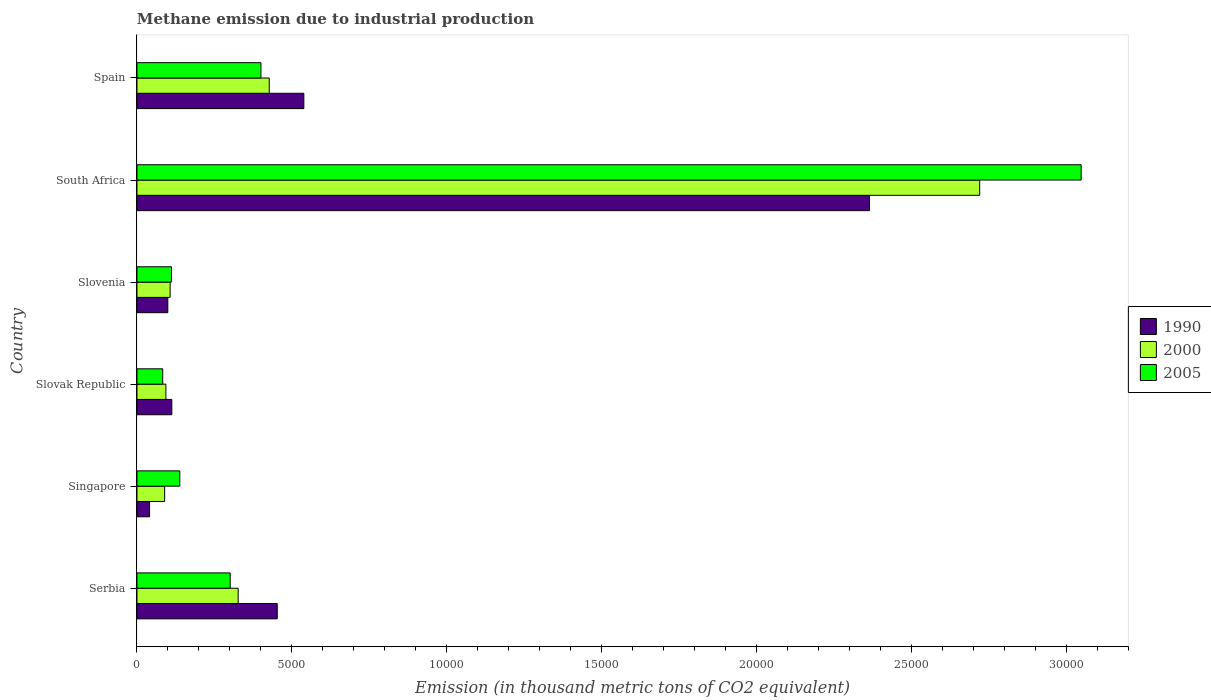Are the number of bars per tick equal to the number of legend labels?
Ensure brevity in your answer.  Yes. Are the number of bars on each tick of the Y-axis equal?
Give a very brief answer. Yes. What is the label of the 3rd group of bars from the top?
Offer a very short reply. Slovenia. In how many cases, is the number of bars for a given country not equal to the number of legend labels?
Give a very brief answer. 0. What is the amount of methane emitted in 2005 in Singapore?
Offer a terse response. 1383. Across all countries, what is the maximum amount of methane emitted in 2005?
Your answer should be compact. 3.05e+04. Across all countries, what is the minimum amount of methane emitted in 2005?
Keep it short and to the point. 830.9. In which country was the amount of methane emitted in 2005 maximum?
Give a very brief answer. South Africa. In which country was the amount of methane emitted in 2005 minimum?
Ensure brevity in your answer.  Slovak Republic. What is the total amount of methane emitted in 2005 in the graph?
Your response must be concise. 4.08e+04. What is the difference between the amount of methane emitted in 2005 in Serbia and that in Slovenia?
Provide a succinct answer. 1896. What is the difference between the amount of methane emitted in 1990 in Serbia and the amount of methane emitted in 2000 in Singapore?
Offer a very short reply. 3635.6. What is the average amount of methane emitted in 1990 per country?
Your answer should be compact. 6015.77. What is the difference between the amount of methane emitted in 2005 and amount of methane emitted in 1990 in Singapore?
Offer a very short reply. 976.2. What is the ratio of the amount of methane emitted in 2000 in Slovenia to that in South Africa?
Your response must be concise. 0.04. Is the difference between the amount of methane emitted in 2005 in Serbia and South Africa greater than the difference between the amount of methane emitted in 1990 in Serbia and South Africa?
Your answer should be very brief. No. What is the difference between the highest and the second highest amount of methane emitted in 2005?
Offer a very short reply. 2.65e+04. What is the difference between the highest and the lowest amount of methane emitted in 2005?
Provide a short and direct response. 2.97e+04. In how many countries, is the amount of methane emitted in 2005 greater than the average amount of methane emitted in 2005 taken over all countries?
Your answer should be compact. 1. What does the 1st bar from the bottom in Serbia represents?
Make the answer very short. 1990. Are all the bars in the graph horizontal?
Your response must be concise. Yes. What is the difference between two consecutive major ticks on the X-axis?
Your response must be concise. 5000. Does the graph contain any zero values?
Give a very brief answer. No. Where does the legend appear in the graph?
Offer a terse response. Center right. How many legend labels are there?
Your answer should be very brief. 3. What is the title of the graph?
Provide a short and direct response. Methane emission due to industrial production. Does "2007" appear as one of the legend labels in the graph?
Make the answer very short. No. What is the label or title of the X-axis?
Offer a very short reply. Emission (in thousand metric tons of CO2 equivalent). What is the Emission (in thousand metric tons of CO2 equivalent) of 1990 in Serbia?
Provide a succinct answer. 4529.1. What is the Emission (in thousand metric tons of CO2 equivalent) in 2000 in Serbia?
Your answer should be compact. 3267.7. What is the Emission (in thousand metric tons of CO2 equivalent) of 2005 in Serbia?
Offer a terse response. 3010.4. What is the Emission (in thousand metric tons of CO2 equivalent) of 1990 in Singapore?
Provide a succinct answer. 406.8. What is the Emission (in thousand metric tons of CO2 equivalent) of 2000 in Singapore?
Keep it short and to the point. 893.5. What is the Emission (in thousand metric tons of CO2 equivalent) in 2005 in Singapore?
Your answer should be very brief. 1383. What is the Emission (in thousand metric tons of CO2 equivalent) of 1990 in Slovak Republic?
Your answer should be compact. 1125.1. What is the Emission (in thousand metric tons of CO2 equivalent) of 2000 in Slovak Republic?
Keep it short and to the point. 934.1. What is the Emission (in thousand metric tons of CO2 equivalent) in 2005 in Slovak Republic?
Your response must be concise. 830.9. What is the Emission (in thousand metric tons of CO2 equivalent) of 1990 in Slovenia?
Your response must be concise. 996.3. What is the Emission (in thousand metric tons of CO2 equivalent) of 2000 in Slovenia?
Your response must be concise. 1071.1. What is the Emission (in thousand metric tons of CO2 equivalent) of 2005 in Slovenia?
Offer a very short reply. 1114.4. What is the Emission (in thousand metric tons of CO2 equivalent) of 1990 in South Africa?
Your answer should be very brief. 2.36e+04. What is the Emission (in thousand metric tons of CO2 equivalent) of 2000 in South Africa?
Provide a succinct answer. 2.72e+04. What is the Emission (in thousand metric tons of CO2 equivalent) of 2005 in South Africa?
Offer a very short reply. 3.05e+04. What is the Emission (in thousand metric tons of CO2 equivalent) in 1990 in Spain?
Give a very brief answer. 5387.8. What is the Emission (in thousand metric tons of CO2 equivalent) in 2000 in Spain?
Ensure brevity in your answer.  4271. What is the Emission (in thousand metric tons of CO2 equivalent) in 2005 in Spain?
Provide a succinct answer. 4002.6. Across all countries, what is the maximum Emission (in thousand metric tons of CO2 equivalent) in 1990?
Provide a succinct answer. 2.36e+04. Across all countries, what is the maximum Emission (in thousand metric tons of CO2 equivalent) in 2000?
Your answer should be compact. 2.72e+04. Across all countries, what is the maximum Emission (in thousand metric tons of CO2 equivalent) in 2005?
Your answer should be compact. 3.05e+04. Across all countries, what is the minimum Emission (in thousand metric tons of CO2 equivalent) in 1990?
Keep it short and to the point. 406.8. Across all countries, what is the minimum Emission (in thousand metric tons of CO2 equivalent) of 2000?
Provide a short and direct response. 893.5. Across all countries, what is the minimum Emission (in thousand metric tons of CO2 equivalent) in 2005?
Make the answer very short. 830.9. What is the total Emission (in thousand metric tons of CO2 equivalent) of 1990 in the graph?
Your answer should be compact. 3.61e+04. What is the total Emission (in thousand metric tons of CO2 equivalent) of 2000 in the graph?
Your answer should be very brief. 3.76e+04. What is the total Emission (in thousand metric tons of CO2 equivalent) in 2005 in the graph?
Keep it short and to the point. 4.08e+04. What is the difference between the Emission (in thousand metric tons of CO2 equivalent) of 1990 in Serbia and that in Singapore?
Offer a very short reply. 4122.3. What is the difference between the Emission (in thousand metric tons of CO2 equivalent) of 2000 in Serbia and that in Singapore?
Provide a succinct answer. 2374.2. What is the difference between the Emission (in thousand metric tons of CO2 equivalent) of 2005 in Serbia and that in Singapore?
Your response must be concise. 1627.4. What is the difference between the Emission (in thousand metric tons of CO2 equivalent) of 1990 in Serbia and that in Slovak Republic?
Offer a terse response. 3404. What is the difference between the Emission (in thousand metric tons of CO2 equivalent) in 2000 in Serbia and that in Slovak Republic?
Your answer should be very brief. 2333.6. What is the difference between the Emission (in thousand metric tons of CO2 equivalent) of 2005 in Serbia and that in Slovak Republic?
Your response must be concise. 2179.5. What is the difference between the Emission (in thousand metric tons of CO2 equivalent) of 1990 in Serbia and that in Slovenia?
Ensure brevity in your answer.  3532.8. What is the difference between the Emission (in thousand metric tons of CO2 equivalent) of 2000 in Serbia and that in Slovenia?
Offer a very short reply. 2196.6. What is the difference between the Emission (in thousand metric tons of CO2 equivalent) in 2005 in Serbia and that in Slovenia?
Offer a very short reply. 1896. What is the difference between the Emission (in thousand metric tons of CO2 equivalent) of 1990 in Serbia and that in South Africa?
Provide a short and direct response. -1.91e+04. What is the difference between the Emission (in thousand metric tons of CO2 equivalent) in 2000 in Serbia and that in South Africa?
Provide a succinct answer. -2.39e+04. What is the difference between the Emission (in thousand metric tons of CO2 equivalent) in 2005 in Serbia and that in South Africa?
Offer a very short reply. -2.75e+04. What is the difference between the Emission (in thousand metric tons of CO2 equivalent) in 1990 in Serbia and that in Spain?
Keep it short and to the point. -858.7. What is the difference between the Emission (in thousand metric tons of CO2 equivalent) of 2000 in Serbia and that in Spain?
Ensure brevity in your answer.  -1003.3. What is the difference between the Emission (in thousand metric tons of CO2 equivalent) of 2005 in Serbia and that in Spain?
Provide a short and direct response. -992.2. What is the difference between the Emission (in thousand metric tons of CO2 equivalent) in 1990 in Singapore and that in Slovak Republic?
Your answer should be compact. -718.3. What is the difference between the Emission (in thousand metric tons of CO2 equivalent) of 2000 in Singapore and that in Slovak Republic?
Provide a short and direct response. -40.6. What is the difference between the Emission (in thousand metric tons of CO2 equivalent) in 2005 in Singapore and that in Slovak Republic?
Your answer should be compact. 552.1. What is the difference between the Emission (in thousand metric tons of CO2 equivalent) in 1990 in Singapore and that in Slovenia?
Offer a very short reply. -589.5. What is the difference between the Emission (in thousand metric tons of CO2 equivalent) of 2000 in Singapore and that in Slovenia?
Make the answer very short. -177.6. What is the difference between the Emission (in thousand metric tons of CO2 equivalent) of 2005 in Singapore and that in Slovenia?
Provide a short and direct response. 268.6. What is the difference between the Emission (in thousand metric tons of CO2 equivalent) of 1990 in Singapore and that in South Africa?
Your answer should be compact. -2.32e+04. What is the difference between the Emission (in thousand metric tons of CO2 equivalent) of 2000 in Singapore and that in South Africa?
Your response must be concise. -2.63e+04. What is the difference between the Emission (in thousand metric tons of CO2 equivalent) of 2005 in Singapore and that in South Africa?
Offer a very short reply. -2.91e+04. What is the difference between the Emission (in thousand metric tons of CO2 equivalent) of 1990 in Singapore and that in Spain?
Offer a terse response. -4981. What is the difference between the Emission (in thousand metric tons of CO2 equivalent) in 2000 in Singapore and that in Spain?
Offer a terse response. -3377.5. What is the difference between the Emission (in thousand metric tons of CO2 equivalent) of 2005 in Singapore and that in Spain?
Ensure brevity in your answer.  -2619.6. What is the difference between the Emission (in thousand metric tons of CO2 equivalent) in 1990 in Slovak Republic and that in Slovenia?
Provide a short and direct response. 128.8. What is the difference between the Emission (in thousand metric tons of CO2 equivalent) of 2000 in Slovak Republic and that in Slovenia?
Offer a very short reply. -137. What is the difference between the Emission (in thousand metric tons of CO2 equivalent) of 2005 in Slovak Republic and that in Slovenia?
Ensure brevity in your answer.  -283.5. What is the difference between the Emission (in thousand metric tons of CO2 equivalent) in 1990 in Slovak Republic and that in South Africa?
Make the answer very short. -2.25e+04. What is the difference between the Emission (in thousand metric tons of CO2 equivalent) in 2000 in Slovak Republic and that in South Africa?
Your answer should be compact. -2.63e+04. What is the difference between the Emission (in thousand metric tons of CO2 equivalent) of 2005 in Slovak Republic and that in South Africa?
Ensure brevity in your answer.  -2.97e+04. What is the difference between the Emission (in thousand metric tons of CO2 equivalent) of 1990 in Slovak Republic and that in Spain?
Your response must be concise. -4262.7. What is the difference between the Emission (in thousand metric tons of CO2 equivalent) in 2000 in Slovak Republic and that in Spain?
Your response must be concise. -3336.9. What is the difference between the Emission (in thousand metric tons of CO2 equivalent) of 2005 in Slovak Republic and that in Spain?
Ensure brevity in your answer.  -3171.7. What is the difference between the Emission (in thousand metric tons of CO2 equivalent) of 1990 in Slovenia and that in South Africa?
Your answer should be compact. -2.27e+04. What is the difference between the Emission (in thousand metric tons of CO2 equivalent) in 2000 in Slovenia and that in South Africa?
Your answer should be very brief. -2.61e+04. What is the difference between the Emission (in thousand metric tons of CO2 equivalent) of 2005 in Slovenia and that in South Africa?
Offer a terse response. -2.94e+04. What is the difference between the Emission (in thousand metric tons of CO2 equivalent) in 1990 in Slovenia and that in Spain?
Give a very brief answer. -4391.5. What is the difference between the Emission (in thousand metric tons of CO2 equivalent) of 2000 in Slovenia and that in Spain?
Keep it short and to the point. -3199.9. What is the difference between the Emission (in thousand metric tons of CO2 equivalent) in 2005 in Slovenia and that in Spain?
Provide a short and direct response. -2888.2. What is the difference between the Emission (in thousand metric tons of CO2 equivalent) in 1990 in South Africa and that in Spain?
Offer a very short reply. 1.83e+04. What is the difference between the Emission (in thousand metric tons of CO2 equivalent) in 2000 in South Africa and that in Spain?
Provide a succinct answer. 2.29e+04. What is the difference between the Emission (in thousand metric tons of CO2 equivalent) in 2005 in South Africa and that in Spain?
Offer a very short reply. 2.65e+04. What is the difference between the Emission (in thousand metric tons of CO2 equivalent) in 1990 in Serbia and the Emission (in thousand metric tons of CO2 equivalent) in 2000 in Singapore?
Make the answer very short. 3635.6. What is the difference between the Emission (in thousand metric tons of CO2 equivalent) of 1990 in Serbia and the Emission (in thousand metric tons of CO2 equivalent) of 2005 in Singapore?
Your response must be concise. 3146.1. What is the difference between the Emission (in thousand metric tons of CO2 equivalent) of 2000 in Serbia and the Emission (in thousand metric tons of CO2 equivalent) of 2005 in Singapore?
Ensure brevity in your answer.  1884.7. What is the difference between the Emission (in thousand metric tons of CO2 equivalent) of 1990 in Serbia and the Emission (in thousand metric tons of CO2 equivalent) of 2000 in Slovak Republic?
Offer a terse response. 3595. What is the difference between the Emission (in thousand metric tons of CO2 equivalent) in 1990 in Serbia and the Emission (in thousand metric tons of CO2 equivalent) in 2005 in Slovak Republic?
Offer a very short reply. 3698.2. What is the difference between the Emission (in thousand metric tons of CO2 equivalent) of 2000 in Serbia and the Emission (in thousand metric tons of CO2 equivalent) of 2005 in Slovak Republic?
Make the answer very short. 2436.8. What is the difference between the Emission (in thousand metric tons of CO2 equivalent) in 1990 in Serbia and the Emission (in thousand metric tons of CO2 equivalent) in 2000 in Slovenia?
Give a very brief answer. 3458. What is the difference between the Emission (in thousand metric tons of CO2 equivalent) of 1990 in Serbia and the Emission (in thousand metric tons of CO2 equivalent) of 2005 in Slovenia?
Your response must be concise. 3414.7. What is the difference between the Emission (in thousand metric tons of CO2 equivalent) in 2000 in Serbia and the Emission (in thousand metric tons of CO2 equivalent) in 2005 in Slovenia?
Offer a terse response. 2153.3. What is the difference between the Emission (in thousand metric tons of CO2 equivalent) in 1990 in Serbia and the Emission (in thousand metric tons of CO2 equivalent) in 2000 in South Africa?
Make the answer very short. -2.27e+04. What is the difference between the Emission (in thousand metric tons of CO2 equivalent) in 1990 in Serbia and the Emission (in thousand metric tons of CO2 equivalent) in 2005 in South Africa?
Your answer should be very brief. -2.60e+04. What is the difference between the Emission (in thousand metric tons of CO2 equivalent) in 2000 in Serbia and the Emission (in thousand metric tons of CO2 equivalent) in 2005 in South Africa?
Offer a very short reply. -2.72e+04. What is the difference between the Emission (in thousand metric tons of CO2 equivalent) in 1990 in Serbia and the Emission (in thousand metric tons of CO2 equivalent) in 2000 in Spain?
Offer a very short reply. 258.1. What is the difference between the Emission (in thousand metric tons of CO2 equivalent) in 1990 in Serbia and the Emission (in thousand metric tons of CO2 equivalent) in 2005 in Spain?
Make the answer very short. 526.5. What is the difference between the Emission (in thousand metric tons of CO2 equivalent) in 2000 in Serbia and the Emission (in thousand metric tons of CO2 equivalent) in 2005 in Spain?
Give a very brief answer. -734.9. What is the difference between the Emission (in thousand metric tons of CO2 equivalent) in 1990 in Singapore and the Emission (in thousand metric tons of CO2 equivalent) in 2000 in Slovak Republic?
Provide a short and direct response. -527.3. What is the difference between the Emission (in thousand metric tons of CO2 equivalent) in 1990 in Singapore and the Emission (in thousand metric tons of CO2 equivalent) in 2005 in Slovak Republic?
Offer a terse response. -424.1. What is the difference between the Emission (in thousand metric tons of CO2 equivalent) of 2000 in Singapore and the Emission (in thousand metric tons of CO2 equivalent) of 2005 in Slovak Republic?
Your answer should be very brief. 62.6. What is the difference between the Emission (in thousand metric tons of CO2 equivalent) in 1990 in Singapore and the Emission (in thousand metric tons of CO2 equivalent) in 2000 in Slovenia?
Offer a terse response. -664.3. What is the difference between the Emission (in thousand metric tons of CO2 equivalent) of 1990 in Singapore and the Emission (in thousand metric tons of CO2 equivalent) of 2005 in Slovenia?
Make the answer very short. -707.6. What is the difference between the Emission (in thousand metric tons of CO2 equivalent) in 2000 in Singapore and the Emission (in thousand metric tons of CO2 equivalent) in 2005 in Slovenia?
Keep it short and to the point. -220.9. What is the difference between the Emission (in thousand metric tons of CO2 equivalent) of 1990 in Singapore and the Emission (in thousand metric tons of CO2 equivalent) of 2000 in South Africa?
Offer a very short reply. -2.68e+04. What is the difference between the Emission (in thousand metric tons of CO2 equivalent) in 1990 in Singapore and the Emission (in thousand metric tons of CO2 equivalent) in 2005 in South Africa?
Ensure brevity in your answer.  -3.01e+04. What is the difference between the Emission (in thousand metric tons of CO2 equivalent) in 2000 in Singapore and the Emission (in thousand metric tons of CO2 equivalent) in 2005 in South Africa?
Give a very brief answer. -2.96e+04. What is the difference between the Emission (in thousand metric tons of CO2 equivalent) in 1990 in Singapore and the Emission (in thousand metric tons of CO2 equivalent) in 2000 in Spain?
Provide a succinct answer. -3864.2. What is the difference between the Emission (in thousand metric tons of CO2 equivalent) in 1990 in Singapore and the Emission (in thousand metric tons of CO2 equivalent) in 2005 in Spain?
Your response must be concise. -3595.8. What is the difference between the Emission (in thousand metric tons of CO2 equivalent) of 2000 in Singapore and the Emission (in thousand metric tons of CO2 equivalent) of 2005 in Spain?
Give a very brief answer. -3109.1. What is the difference between the Emission (in thousand metric tons of CO2 equivalent) of 2000 in Slovak Republic and the Emission (in thousand metric tons of CO2 equivalent) of 2005 in Slovenia?
Give a very brief answer. -180.3. What is the difference between the Emission (in thousand metric tons of CO2 equivalent) of 1990 in Slovak Republic and the Emission (in thousand metric tons of CO2 equivalent) of 2000 in South Africa?
Offer a terse response. -2.61e+04. What is the difference between the Emission (in thousand metric tons of CO2 equivalent) of 1990 in Slovak Republic and the Emission (in thousand metric tons of CO2 equivalent) of 2005 in South Africa?
Offer a terse response. -2.94e+04. What is the difference between the Emission (in thousand metric tons of CO2 equivalent) of 2000 in Slovak Republic and the Emission (in thousand metric tons of CO2 equivalent) of 2005 in South Africa?
Your answer should be compact. -2.96e+04. What is the difference between the Emission (in thousand metric tons of CO2 equivalent) of 1990 in Slovak Republic and the Emission (in thousand metric tons of CO2 equivalent) of 2000 in Spain?
Your answer should be compact. -3145.9. What is the difference between the Emission (in thousand metric tons of CO2 equivalent) in 1990 in Slovak Republic and the Emission (in thousand metric tons of CO2 equivalent) in 2005 in Spain?
Your answer should be very brief. -2877.5. What is the difference between the Emission (in thousand metric tons of CO2 equivalent) in 2000 in Slovak Republic and the Emission (in thousand metric tons of CO2 equivalent) in 2005 in Spain?
Your answer should be compact. -3068.5. What is the difference between the Emission (in thousand metric tons of CO2 equivalent) in 1990 in Slovenia and the Emission (in thousand metric tons of CO2 equivalent) in 2000 in South Africa?
Your answer should be compact. -2.62e+04. What is the difference between the Emission (in thousand metric tons of CO2 equivalent) in 1990 in Slovenia and the Emission (in thousand metric tons of CO2 equivalent) in 2005 in South Africa?
Keep it short and to the point. -2.95e+04. What is the difference between the Emission (in thousand metric tons of CO2 equivalent) in 2000 in Slovenia and the Emission (in thousand metric tons of CO2 equivalent) in 2005 in South Africa?
Your answer should be compact. -2.94e+04. What is the difference between the Emission (in thousand metric tons of CO2 equivalent) of 1990 in Slovenia and the Emission (in thousand metric tons of CO2 equivalent) of 2000 in Spain?
Offer a very short reply. -3274.7. What is the difference between the Emission (in thousand metric tons of CO2 equivalent) in 1990 in Slovenia and the Emission (in thousand metric tons of CO2 equivalent) in 2005 in Spain?
Keep it short and to the point. -3006.3. What is the difference between the Emission (in thousand metric tons of CO2 equivalent) in 2000 in Slovenia and the Emission (in thousand metric tons of CO2 equivalent) in 2005 in Spain?
Provide a short and direct response. -2931.5. What is the difference between the Emission (in thousand metric tons of CO2 equivalent) of 1990 in South Africa and the Emission (in thousand metric tons of CO2 equivalent) of 2000 in Spain?
Offer a terse response. 1.94e+04. What is the difference between the Emission (in thousand metric tons of CO2 equivalent) of 1990 in South Africa and the Emission (in thousand metric tons of CO2 equivalent) of 2005 in Spain?
Give a very brief answer. 1.96e+04. What is the difference between the Emission (in thousand metric tons of CO2 equivalent) of 2000 in South Africa and the Emission (in thousand metric tons of CO2 equivalent) of 2005 in Spain?
Make the answer very short. 2.32e+04. What is the average Emission (in thousand metric tons of CO2 equivalent) of 1990 per country?
Make the answer very short. 6015.77. What is the average Emission (in thousand metric tons of CO2 equivalent) of 2000 per country?
Your answer should be compact. 6274.2. What is the average Emission (in thousand metric tons of CO2 equivalent) in 2005 per country?
Make the answer very short. 6804.27. What is the difference between the Emission (in thousand metric tons of CO2 equivalent) in 1990 and Emission (in thousand metric tons of CO2 equivalent) in 2000 in Serbia?
Offer a very short reply. 1261.4. What is the difference between the Emission (in thousand metric tons of CO2 equivalent) of 1990 and Emission (in thousand metric tons of CO2 equivalent) of 2005 in Serbia?
Ensure brevity in your answer.  1518.7. What is the difference between the Emission (in thousand metric tons of CO2 equivalent) in 2000 and Emission (in thousand metric tons of CO2 equivalent) in 2005 in Serbia?
Give a very brief answer. 257.3. What is the difference between the Emission (in thousand metric tons of CO2 equivalent) of 1990 and Emission (in thousand metric tons of CO2 equivalent) of 2000 in Singapore?
Provide a succinct answer. -486.7. What is the difference between the Emission (in thousand metric tons of CO2 equivalent) in 1990 and Emission (in thousand metric tons of CO2 equivalent) in 2005 in Singapore?
Provide a short and direct response. -976.2. What is the difference between the Emission (in thousand metric tons of CO2 equivalent) in 2000 and Emission (in thousand metric tons of CO2 equivalent) in 2005 in Singapore?
Your answer should be very brief. -489.5. What is the difference between the Emission (in thousand metric tons of CO2 equivalent) of 1990 and Emission (in thousand metric tons of CO2 equivalent) of 2000 in Slovak Republic?
Ensure brevity in your answer.  191. What is the difference between the Emission (in thousand metric tons of CO2 equivalent) of 1990 and Emission (in thousand metric tons of CO2 equivalent) of 2005 in Slovak Republic?
Offer a very short reply. 294.2. What is the difference between the Emission (in thousand metric tons of CO2 equivalent) of 2000 and Emission (in thousand metric tons of CO2 equivalent) of 2005 in Slovak Republic?
Your answer should be compact. 103.2. What is the difference between the Emission (in thousand metric tons of CO2 equivalent) in 1990 and Emission (in thousand metric tons of CO2 equivalent) in 2000 in Slovenia?
Keep it short and to the point. -74.8. What is the difference between the Emission (in thousand metric tons of CO2 equivalent) in 1990 and Emission (in thousand metric tons of CO2 equivalent) in 2005 in Slovenia?
Your response must be concise. -118.1. What is the difference between the Emission (in thousand metric tons of CO2 equivalent) in 2000 and Emission (in thousand metric tons of CO2 equivalent) in 2005 in Slovenia?
Ensure brevity in your answer.  -43.3. What is the difference between the Emission (in thousand metric tons of CO2 equivalent) in 1990 and Emission (in thousand metric tons of CO2 equivalent) in 2000 in South Africa?
Your response must be concise. -3558.3. What is the difference between the Emission (in thousand metric tons of CO2 equivalent) in 1990 and Emission (in thousand metric tons of CO2 equivalent) in 2005 in South Africa?
Give a very brief answer. -6834.8. What is the difference between the Emission (in thousand metric tons of CO2 equivalent) in 2000 and Emission (in thousand metric tons of CO2 equivalent) in 2005 in South Africa?
Keep it short and to the point. -3276.5. What is the difference between the Emission (in thousand metric tons of CO2 equivalent) of 1990 and Emission (in thousand metric tons of CO2 equivalent) of 2000 in Spain?
Ensure brevity in your answer.  1116.8. What is the difference between the Emission (in thousand metric tons of CO2 equivalent) in 1990 and Emission (in thousand metric tons of CO2 equivalent) in 2005 in Spain?
Offer a terse response. 1385.2. What is the difference between the Emission (in thousand metric tons of CO2 equivalent) in 2000 and Emission (in thousand metric tons of CO2 equivalent) in 2005 in Spain?
Your answer should be very brief. 268.4. What is the ratio of the Emission (in thousand metric tons of CO2 equivalent) in 1990 in Serbia to that in Singapore?
Your response must be concise. 11.13. What is the ratio of the Emission (in thousand metric tons of CO2 equivalent) in 2000 in Serbia to that in Singapore?
Give a very brief answer. 3.66. What is the ratio of the Emission (in thousand metric tons of CO2 equivalent) in 2005 in Serbia to that in Singapore?
Your answer should be very brief. 2.18. What is the ratio of the Emission (in thousand metric tons of CO2 equivalent) in 1990 in Serbia to that in Slovak Republic?
Offer a terse response. 4.03. What is the ratio of the Emission (in thousand metric tons of CO2 equivalent) in 2000 in Serbia to that in Slovak Republic?
Offer a very short reply. 3.5. What is the ratio of the Emission (in thousand metric tons of CO2 equivalent) of 2005 in Serbia to that in Slovak Republic?
Offer a very short reply. 3.62. What is the ratio of the Emission (in thousand metric tons of CO2 equivalent) in 1990 in Serbia to that in Slovenia?
Offer a terse response. 4.55. What is the ratio of the Emission (in thousand metric tons of CO2 equivalent) in 2000 in Serbia to that in Slovenia?
Keep it short and to the point. 3.05. What is the ratio of the Emission (in thousand metric tons of CO2 equivalent) in 2005 in Serbia to that in Slovenia?
Your answer should be compact. 2.7. What is the ratio of the Emission (in thousand metric tons of CO2 equivalent) in 1990 in Serbia to that in South Africa?
Provide a succinct answer. 0.19. What is the ratio of the Emission (in thousand metric tons of CO2 equivalent) in 2000 in Serbia to that in South Africa?
Your response must be concise. 0.12. What is the ratio of the Emission (in thousand metric tons of CO2 equivalent) in 2005 in Serbia to that in South Africa?
Your response must be concise. 0.1. What is the ratio of the Emission (in thousand metric tons of CO2 equivalent) in 1990 in Serbia to that in Spain?
Give a very brief answer. 0.84. What is the ratio of the Emission (in thousand metric tons of CO2 equivalent) in 2000 in Serbia to that in Spain?
Give a very brief answer. 0.77. What is the ratio of the Emission (in thousand metric tons of CO2 equivalent) in 2005 in Serbia to that in Spain?
Offer a very short reply. 0.75. What is the ratio of the Emission (in thousand metric tons of CO2 equivalent) in 1990 in Singapore to that in Slovak Republic?
Your answer should be very brief. 0.36. What is the ratio of the Emission (in thousand metric tons of CO2 equivalent) of 2000 in Singapore to that in Slovak Republic?
Your answer should be very brief. 0.96. What is the ratio of the Emission (in thousand metric tons of CO2 equivalent) in 2005 in Singapore to that in Slovak Republic?
Make the answer very short. 1.66. What is the ratio of the Emission (in thousand metric tons of CO2 equivalent) of 1990 in Singapore to that in Slovenia?
Keep it short and to the point. 0.41. What is the ratio of the Emission (in thousand metric tons of CO2 equivalent) of 2000 in Singapore to that in Slovenia?
Provide a short and direct response. 0.83. What is the ratio of the Emission (in thousand metric tons of CO2 equivalent) of 2005 in Singapore to that in Slovenia?
Offer a terse response. 1.24. What is the ratio of the Emission (in thousand metric tons of CO2 equivalent) of 1990 in Singapore to that in South Africa?
Give a very brief answer. 0.02. What is the ratio of the Emission (in thousand metric tons of CO2 equivalent) in 2000 in Singapore to that in South Africa?
Provide a short and direct response. 0.03. What is the ratio of the Emission (in thousand metric tons of CO2 equivalent) in 2005 in Singapore to that in South Africa?
Your answer should be very brief. 0.05. What is the ratio of the Emission (in thousand metric tons of CO2 equivalent) in 1990 in Singapore to that in Spain?
Make the answer very short. 0.08. What is the ratio of the Emission (in thousand metric tons of CO2 equivalent) in 2000 in Singapore to that in Spain?
Your answer should be compact. 0.21. What is the ratio of the Emission (in thousand metric tons of CO2 equivalent) in 2005 in Singapore to that in Spain?
Provide a succinct answer. 0.35. What is the ratio of the Emission (in thousand metric tons of CO2 equivalent) in 1990 in Slovak Republic to that in Slovenia?
Offer a terse response. 1.13. What is the ratio of the Emission (in thousand metric tons of CO2 equivalent) in 2000 in Slovak Republic to that in Slovenia?
Ensure brevity in your answer.  0.87. What is the ratio of the Emission (in thousand metric tons of CO2 equivalent) of 2005 in Slovak Republic to that in Slovenia?
Offer a very short reply. 0.75. What is the ratio of the Emission (in thousand metric tons of CO2 equivalent) of 1990 in Slovak Republic to that in South Africa?
Ensure brevity in your answer.  0.05. What is the ratio of the Emission (in thousand metric tons of CO2 equivalent) in 2000 in Slovak Republic to that in South Africa?
Your answer should be very brief. 0.03. What is the ratio of the Emission (in thousand metric tons of CO2 equivalent) of 2005 in Slovak Republic to that in South Africa?
Provide a succinct answer. 0.03. What is the ratio of the Emission (in thousand metric tons of CO2 equivalent) of 1990 in Slovak Republic to that in Spain?
Provide a succinct answer. 0.21. What is the ratio of the Emission (in thousand metric tons of CO2 equivalent) in 2000 in Slovak Republic to that in Spain?
Make the answer very short. 0.22. What is the ratio of the Emission (in thousand metric tons of CO2 equivalent) of 2005 in Slovak Republic to that in Spain?
Your response must be concise. 0.21. What is the ratio of the Emission (in thousand metric tons of CO2 equivalent) in 1990 in Slovenia to that in South Africa?
Keep it short and to the point. 0.04. What is the ratio of the Emission (in thousand metric tons of CO2 equivalent) of 2000 in Slovenia to that in South Africa?
Offer a terse response. 0.04. What is the ratio of the Emission (in thousand metric tons of CO2 equivalent) in 2005 in Slovenia to that in South Africa?
Provide a short and direct response. 0.04. What is the ratio of the Emission (in thousand metric tons of CO2 equivalent) in 1990 in Slovenia to that in Spain?
Provide a succinct answer. 0.18. What is the ratio of the Emission (in thousand metric tons of CO2 equivalent) in 2000 in Slovenia to that in Spain?
Offer a terse response. 0.25. What is the ratio of the Emission (in thousand metric tons of CO2 equivalent) in 2005 in Slovenia to that in Spain?
Ensure brevity in your answer.  0.28. What is the ratio of the Emission (in thousand metric tons of CO2 equivalent) in 1990 in South Africa to that in Spain?
Offer a very short reply. 4.39. What is the ratio of the Emission (in thousand metric tons of CO2 equivalent) of 2000 in South Africa to that in Spain?
Your answer should be compact. 6.37. What is the ratio of the Emission (in thousand metric tons of CO2 equivalent) in 2005 in South Africa to that in Spain?
Keep it short and to the point. 7.62. What is the difference between the highest and the second highest Emission (in thousand metric tons of CO2 equivalent) of 1990?
Your response must be concise. 1.83e+04. What is the difference between the highest and the second highest Emission (in thousand metric tons of CO2 equivalent) of 2000?
Your answer should be very brief. 2.29e+04. What is the difference between the highest and the second highest Emission (in thousand metric tons of CO2 equivalent) of 2005?
Make the answer very short. 2.65e+04. What is the difference between the highest and the lowest Emission (in thousand metric tons of CO2 equivalent) of 1990?
Offer a very short reply. 2.32e+04. What is the difference between the highest and the lowest Emission (in thousand metric tons of CO2 equivalent) of 2000?
Offer a terse response. 2.63e+04. What is the difference between the highest and the lowest Emission (in thousand metric tons of CO2 equivalent) in 2005?
Make the answer very short. 2.97e+04. 